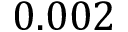Convert formula to latex. <formula><loc_0><loc_0><loc_500><loc_500>0 . 0 0 2</formula> 